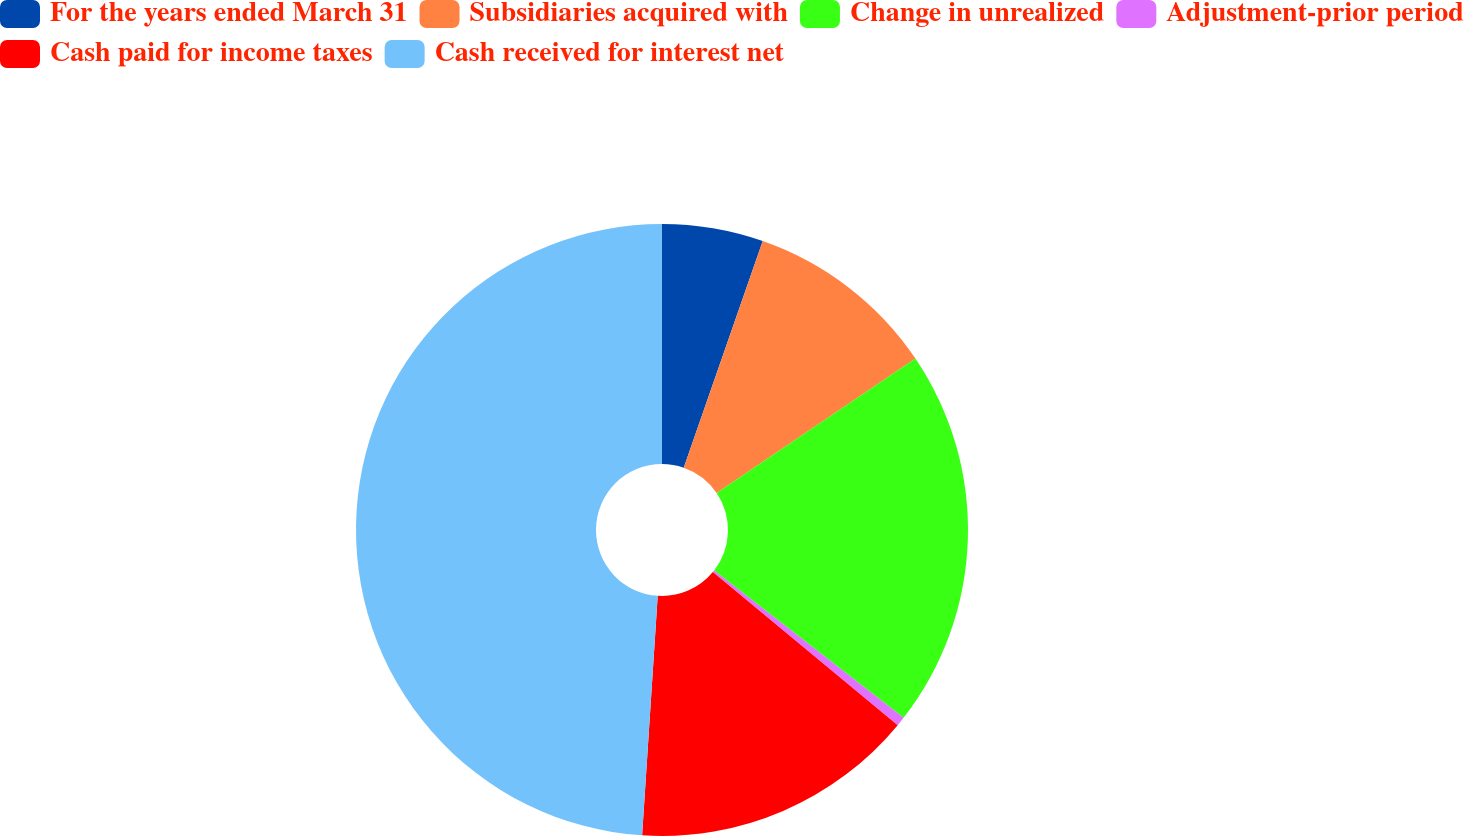Convert chart. <chart><loc_0><loc_0><loc_500><loc_500><pie_chart><fcel>For the years ended March 31<fcel>Subsidiaries acquired with<fcel>Change in unrealized<fcel>Adjustment-prior period<fcel>Cash paid for income taxes<fcel>Cash received for interest net<nl><fcel>5.34%<fcel>10.19%<fcel>19.99%<fcel>0.49%<fcel>15.03%<fcel>48.97%<nl></chart> 